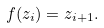<formula> <loc_0><loc_0><loc_500><loc_500>f ( z _ { i } ) = z _ { i + 1 } .</formula> 